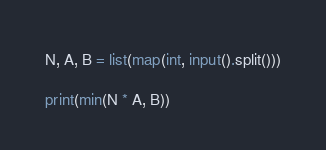Convert code to text. <code><loc_0><loc_0><loc_500><loc_500><_Python_>N, A, B = list(map(int, input().split()))

print(min(N * A, B))</code> 